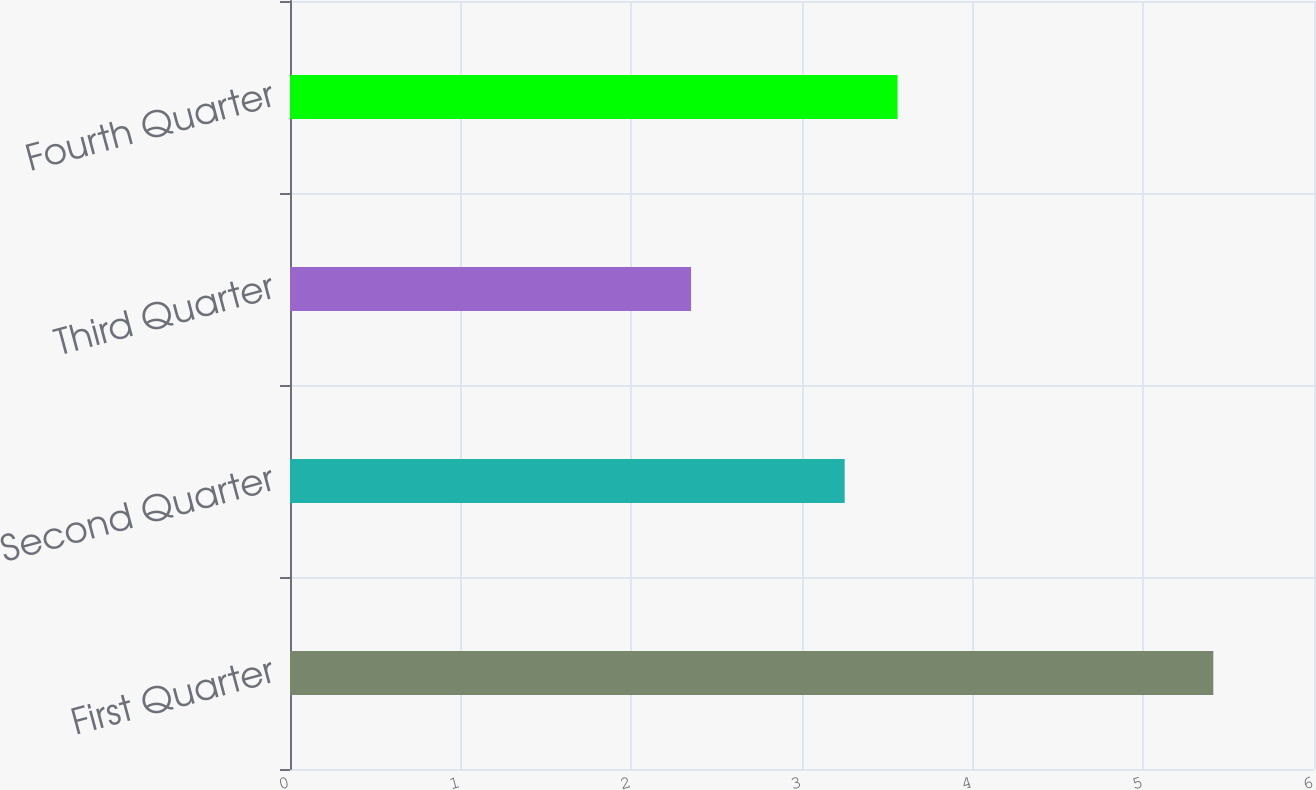Convert chart to OTSL. <chart><loc_0><loc_0><loc_500><loc_500><bar_chart><fcel>First Quarter<fcel>Second Quarter<fcel>Third Quarter<fcel>Fourth Quarter<nl><fcel>5.41<fcel>3.25<fcel>2.35<fcel>3.56<nl></chart> 